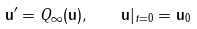<formula> <loc_0><loc_0><loc_500><loc_500>\mathbf u ^ { \prime } = Q _ { \infty } ( \mathbf u ) , \quad \mathbf u | _ { t = 0 } = \mathbf u _ { 0 }</formula> 